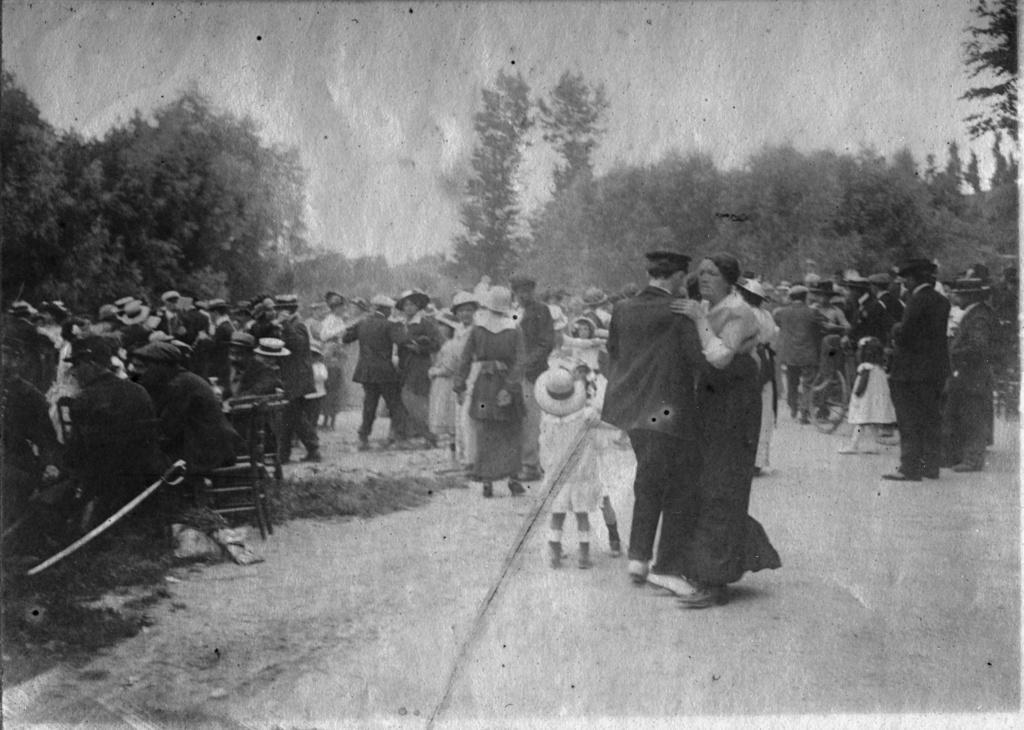How would you summarize this image in a sentence or two? In this image I can see group of people standing and I can also see a knife. Background I can see trees and the image is in black and white. 